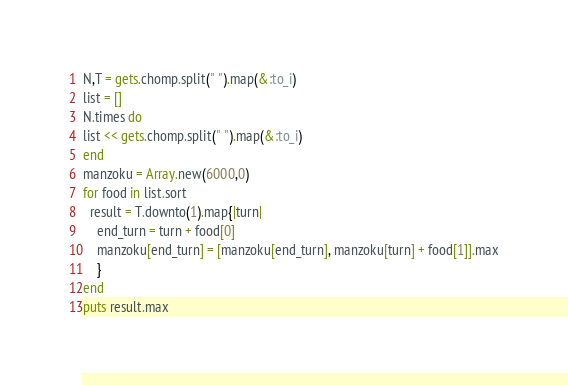Convert code to text. <code><loc_0><loc_0><loc_500><loc_500><_Ruby_>N,T = gets.chomp.split(" ").map(&:to_i)
list = []
N.times do
list << gets.chomp.split(" ").map(&:to_i)
end
manzoku = Array.new(6000,0)
for food in list.sort
  result = T.downto(1).map{|turn|
    end_turn = turn + food[0]
    manzoku[end_turn] = [manzoku[end_turn], manzoku[turn] + food[1]].max
    }
end
puts result.max</code> 